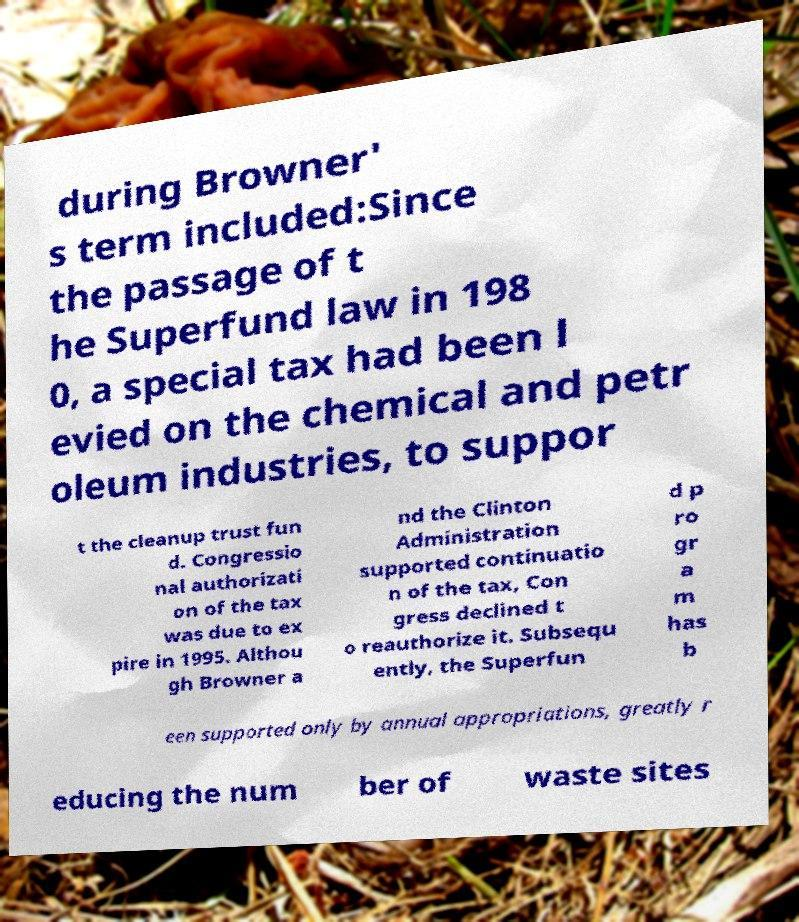Can you read and provide the text displayed in the image?This photo seems to have some interesting text. Can you extract and type it out for me? during Browner' s term included:Since the passage of t he Superfund law in 198 0, a special tax had been l evied on the chemical and petr oleum industries, to suppor t the cleanup trust fun d. Congressio nal authorizati on of the tax was due to ex pire in 1995. Althou gh Browner a nd the Clinton Administration supported continuatio n of the tax, Con gress declined t o reauthorize it. Subsequ ently, the Superfun d p ro gr a m has b een supported only by annual appropriations, greatly r educing the num ber of waste sites 